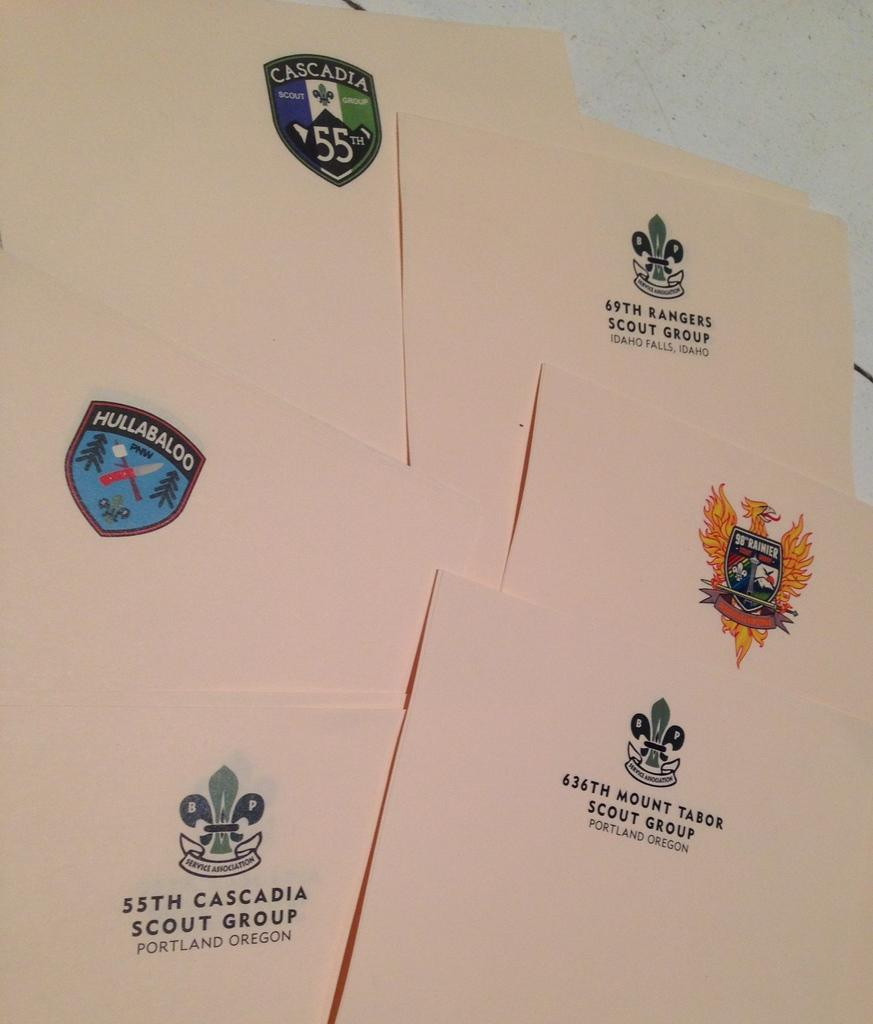<image>
Create a compact narrative representing the image presented. Several letterheaded papers are from varying locations, including Portland, Oregon. 